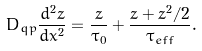Convert formula to latex. <formula><loc_0><loc_0><loc_500><loc_500>D _ { q p } \frac { d ^ { 2 } z } { d x ^ { 2 } } = \frac { z } { \tau _ { 0 } } + \frac { z + z ^ { 2 } / 2 } { \tau _ { e f f } } .</formula> 